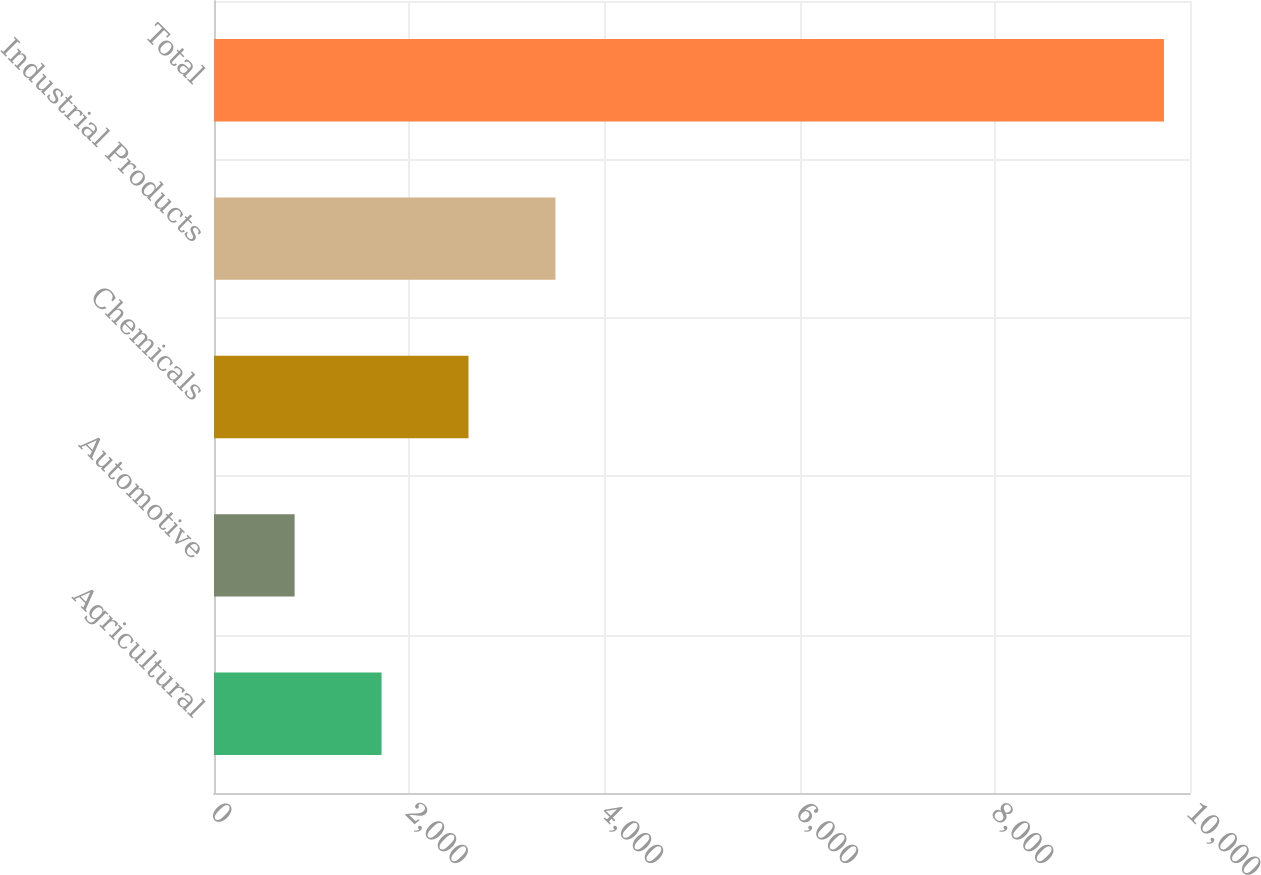Convert chart to OTSL. <chart><loc_0><loc_0><loc_500><loc_500><bar_chart><fcel>Agricultural<fcel>Automotive<fcel>Chemicals<fcel>Industrial Products<fcel>Total<nl><fcel>1716.7<fcel>826<fcel>2607.4<fcel>3498.1<fcel>9733<nl></chart> 